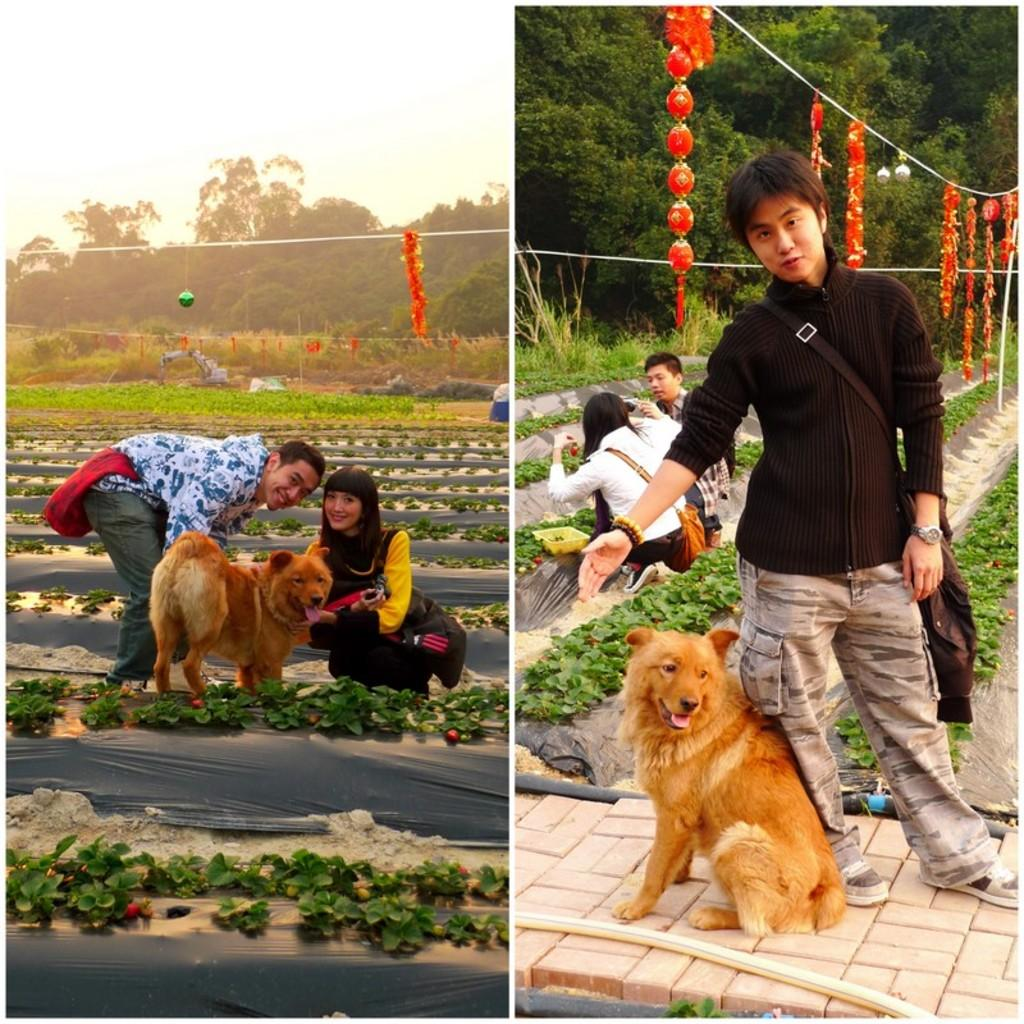What type of composition is the image? The image is a collage of multiple images. What can be seen in the collage involving living beings? There is a group of people and dogs in the collage. What type of natural elements are present in the collage? There are plants, trees, and paper lanterns in the collage. What type of list can be seen hanging from the trees in the collage? There is no list present in the collage; it features a group of people, dogs, plants, trees, and paper lanterns. How many trucks are visible in the collage? There are no trucks visible in the collage. 